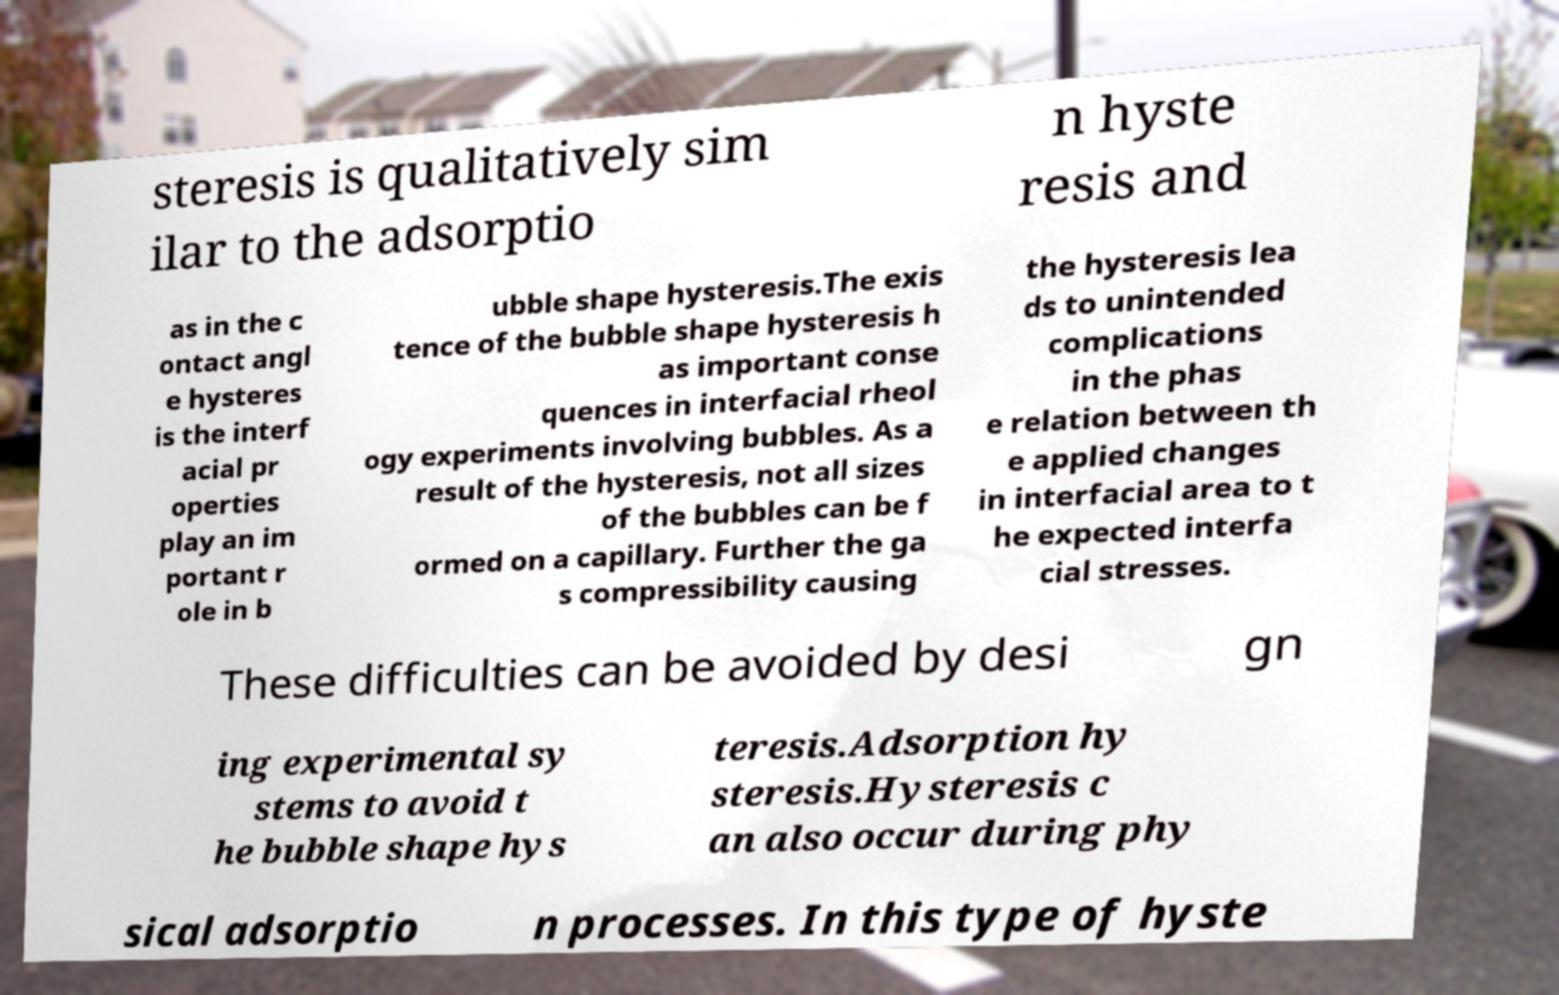Can you read and provide the text displayed in the image?This photo seems to have some interesting text. Can you extract and type it out for me? steresis is qualitatively sim ilar to the adsorptio n hyste resis and as in the c ontact angl e hysteres is the interf acial pr operties play an im portant r ole in b ubble shape hysteresis.The exis tence of the bubble shape hysteresis h as important conse quences in interfacial rheol ogy experiments involving bubbles. As a result of the hysteresis, not all sizes of the bubbles can be f ormed on a capillary. Further the ga s compressibility causing the hysteresis lea ds to unintended complications in the phas e relation between th e applied changes in interfacial area to t he expected interfa cial stresses. These difficulties can be avoided by desi gn ing experimental sy stems to avoid t he bubble shape hys teresis.Adsorption hy steresis.Hysteresis c an also occur during phy sical adsorptio n processes. In this type of hyste 